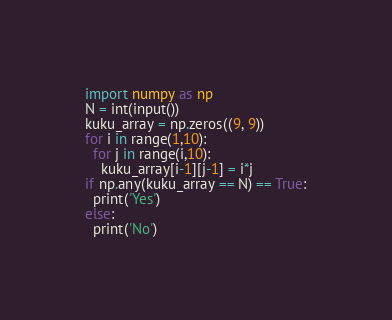<code> <loc_0><loc_0><loc_500><loc_500><_Python_>import numpy as np
N = int(input())
kuku_array = np.zeros((9, 9))
for i in range(1,10):
  for j in range(i,10):
    kuku_array[i-1][j-1] = i*j
if np.any(kuku_array == N) == True:
  print('Yes')
else:
  print('No')</code> 